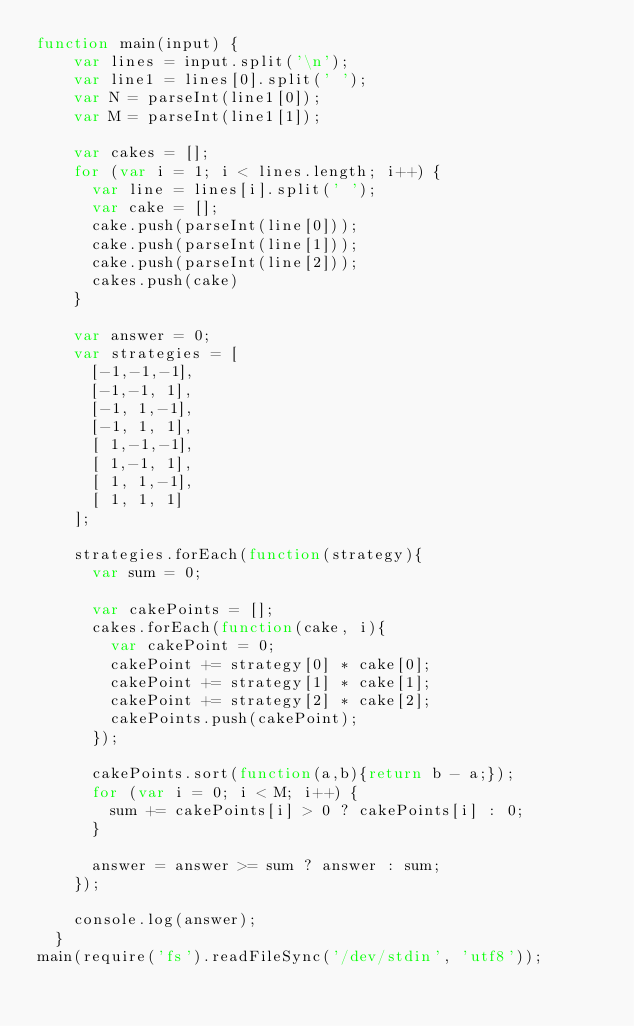Convert code to text. <code><loc_0><loc_0><loc_500><loc_500><_JavaScript_>function main(input) {
    var lines = input.split('\n');
    var line1 = lines[0].split(' ');
    var N = parseInt(line1[0]);
    var M = parseInt(line1[1]);

    var cakes = [];
    for (var i = 1; i < lines.length; i++) {
      var line = lines[i].split(' ');
      var cake = [];
      cake.push(parseInt(line[0]));
      cake.push(parseInt(line[1]));
      cake.push(parseInt(line[2]));
      cakes.push(cake)
    }

    var answer = 0;
    var strategies = [
      [-1,-1,-1],
      [-1,-1, 1],
      [-1, 1,-1],
      [-1, 1, 1],
      [ 1,-1,-1],
      [ 1,-1, 1],
      [ 1, 1,-1],
      [ 1, 1, 1]
    ];
    
    strategies.forEach(function(strategy){
      var sum = 0;

      var cakePoints = [];
      cakes.forEach(function(cake, i){
        var cakePoint = 0;
        cakePoint += strategy[0] * cake[0];
        cakePoint += strategy[1] * cake[1];
        cakePoint += strategy[2] * cake[2];
        cakePoints.push(cakePoint);
      });

      cakePoints.sort(function(a,b){return b - a;});
      for (var i = 0; i < M; i++) {
        sum += cakePoints[i] > 0 ? cakePoints[i] : 0;  
      }

      answer = answer >= sum ? answer : sum;
    });

    console.log(answer);
  }
main(require('fs').readFileSync('/dev/stdin', 'utf8'));</code> 